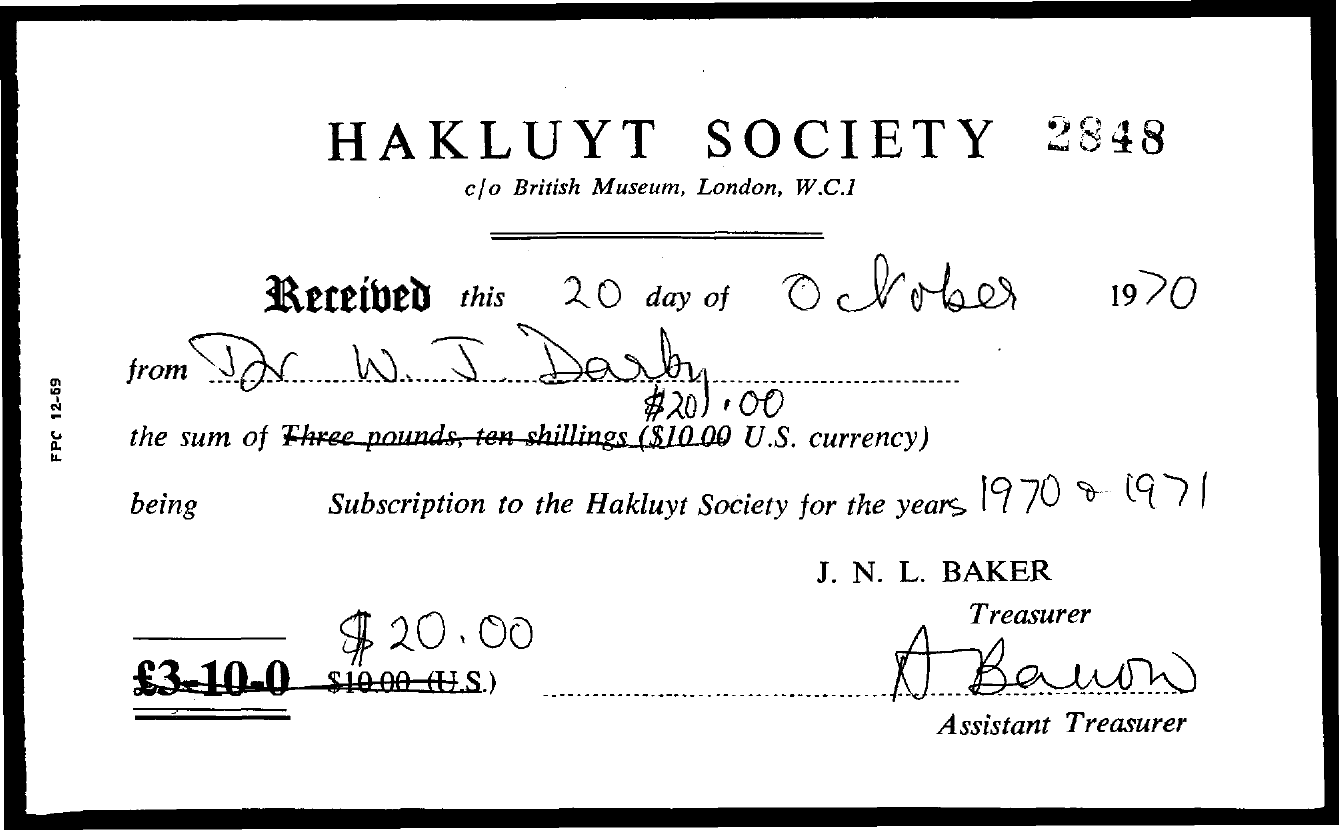What is the title of the document?
Keep it short and to the point. Hakluyt Society. What is the number at the top right of the document?
Offer a terse response. 2848. What is the name of the treasurer?
Ensure brevity in your answer.  J. N. L. Baker. 